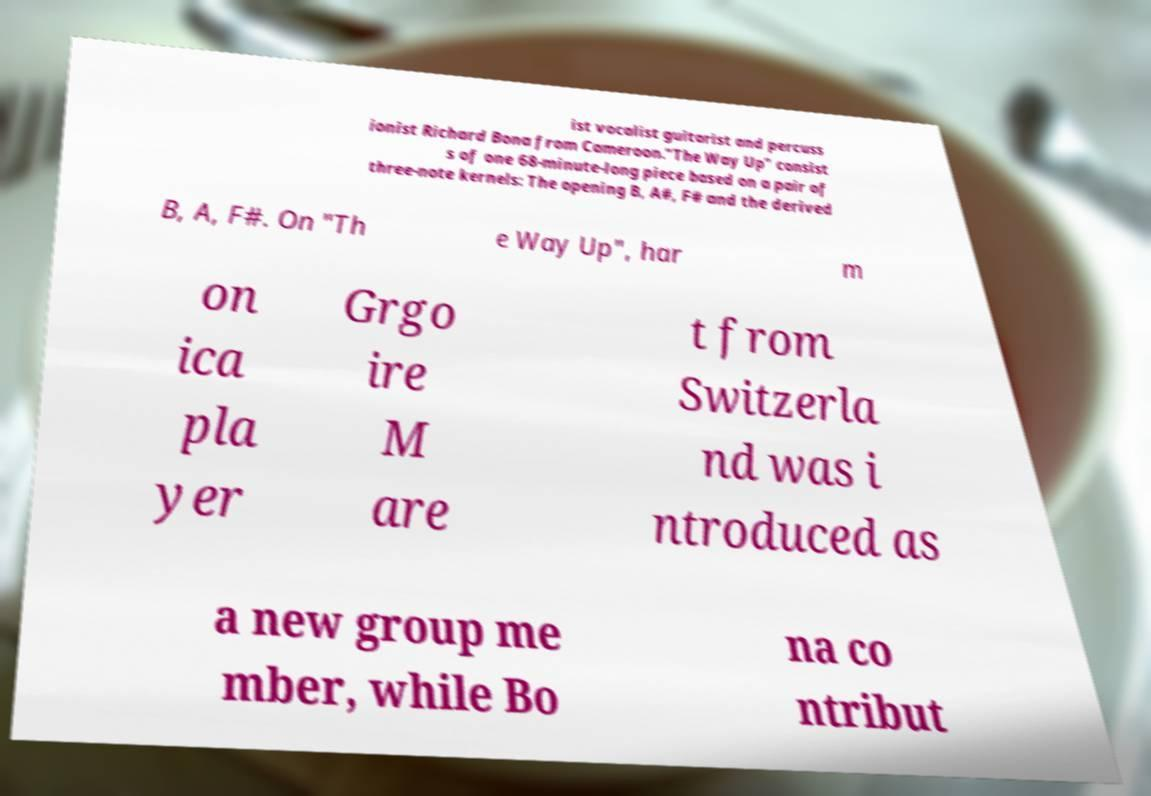Could you assist in decoding the text presented in this image and type it out clearly? ist vocalist guitarist and percuss ionist Richard Bona from Cameroon."The Way Up" consist s of one 68-minute-long piece based on a pair of three-note kernels: The opening B, A#, F# and the derived B, A, F#. On "Th e Way Up", har m on ica pla yer Grgo ire M are t from Switzerla nd was i ntroduced as a new group me mber, while Bo na co ntribut 